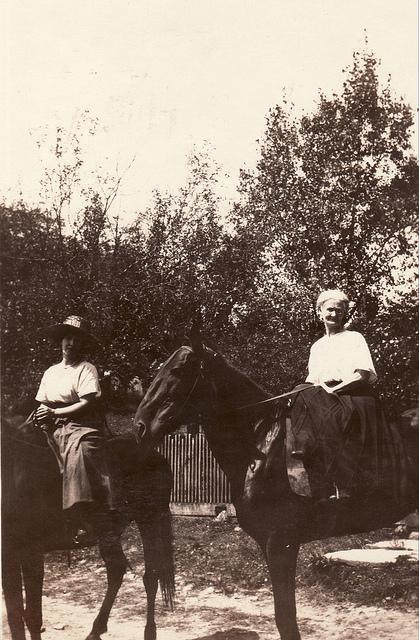How many horses are in the picture?
Give a very brief answer. 2. How many people are in the photo?
Give a very brief answer. 2. How many bears are there?
Give a very brief answer. 0. 